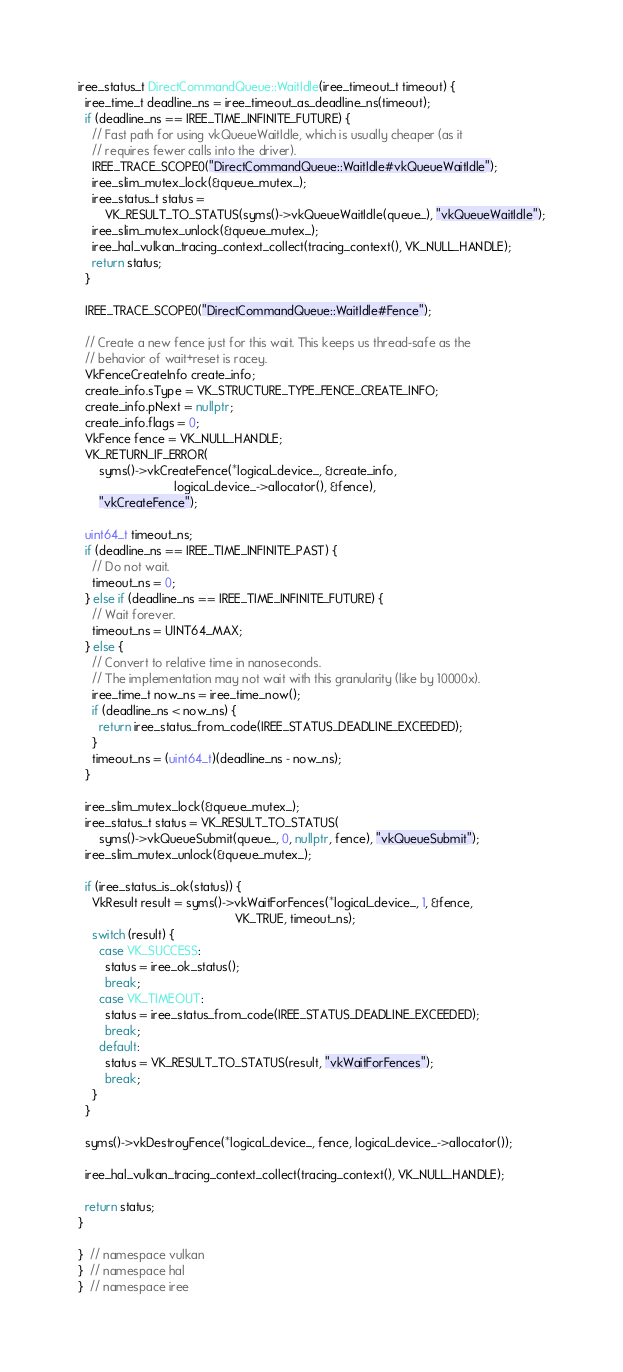Convert code to text. <code><loc_0><loc_0><loc_500><loc_500><_C++_>iree_status_t DirectCommandQueue::WaitIdle(iree_timeout_t timeout) {
  iree_time_t deadline_ns = iree_timeout_as_deadline_ns(timeout);
  if (deadline_ns == IREE_TIME_INFINITE_FUTURE) {
    // Fast path for using vkQueueWaitIdle, which is usually cheaper (as it
    // requires fewer calls into the driver).
    IREE_TRACE_SCOPE0("DirectCommandQueue::WaitIdle#vkQueueWaitIdle");
    iree_slim_mutex_lock(&queue_mutex_);
    iree_status_t status =
        VK_RESULT_TO_STATUS(syms()->vkQueueWaitIdle(queue_), "vkQueueWaitIdle");
    iree_slim_mutex_unlock(&queue_mutex_);
    iree_hal_vulkan_tracing_context_collect(tracing_context(), VK_NULL_HANDLE);
    return status;
  }

  IREE_TRACE_SCOPE0("DirectCommandQueue::WaitIdle#Fence");

  // Create a new fence just for this wait. This keeps us thread-safe as the
  // behavior of wait+reset is racey.
  VkFenceCreateInfo create_info;
  create_info.sType = VK_STRUCTURE_TYPE_FENCE_CREATE_INFO;
  create_info.pNext = nullptr;
  create_info.flags = 0;
  VkFence fence = VK_NULL_HANDLE;
  VK_RETURN_IF_ERROR(
      syms()->vkCreateFence(*logical_device_, &create_info,
                            logical_device_->allocator(), &fence),
      "vkCreateFence");

  uint64_t timeout_ns;
  if (deadline_ns == IREE_TIME_INFINITE_PAST) {
    // Do not wait.
    timeout_ns = 0;
  } else if (deadline_ns == IREE_TIME_INFINITE_FUTURE) {
    // Wait forever.
    timeout_ns = UINT64_MAX;
  } else {
    // Convert to relative time in nanoseconds.
    // The implementation may not wait with this granularity (like by 10000x).
    iree_time_t now_ns = iree_time_now();
    if (deadline_ns < now_ns) {
      return iree_status_from_code(IREE_STATUS_DEADLINE_EXCEEDED);
    }
    timeout_ns = (uint64_t)(deadline_ns - now_ns);
  }

  iree_slim_mutex_lock(&queue_mutex_);
  iree_status_t status = VK_RESULT_TO_STATUS(
      syms()->vkQueueSubmit(queue_, 0, nullptr, fence), "vkQueueSubmit");
  iree_slim_mutex_unlock(&queue_mutex_);

  if (iree_status_is_ok(status)) {
    VkResult result = syms()->vkWaitForFences(*logical_device_, 1, &fence,
                                              VK_TRUE, timeout_ns);
    switch (result) {
      case VK_SUCCESS:
        status = iree_ok_status();
        break;
      case VK_TIMEOUT:
        status = iree_status_from_code(IREE_STATUS_DEADLINE_EXCEEDED);
        break;
      default:
        status = VK_RESULT_TO_STATUS(result, "vkWaitForFences");
        break;
    }
  }

  syms()->vkDestroyFence(*logical_device_, fence, logical_device_->allocator());

  iree_hal_vulkan_tracing_context_collect(tracing_context(), VK_NULL_HANDLE);

  return status;
}

}  // namespace vulkan
}  // namespace hal
}  // namespace iree
</code> 